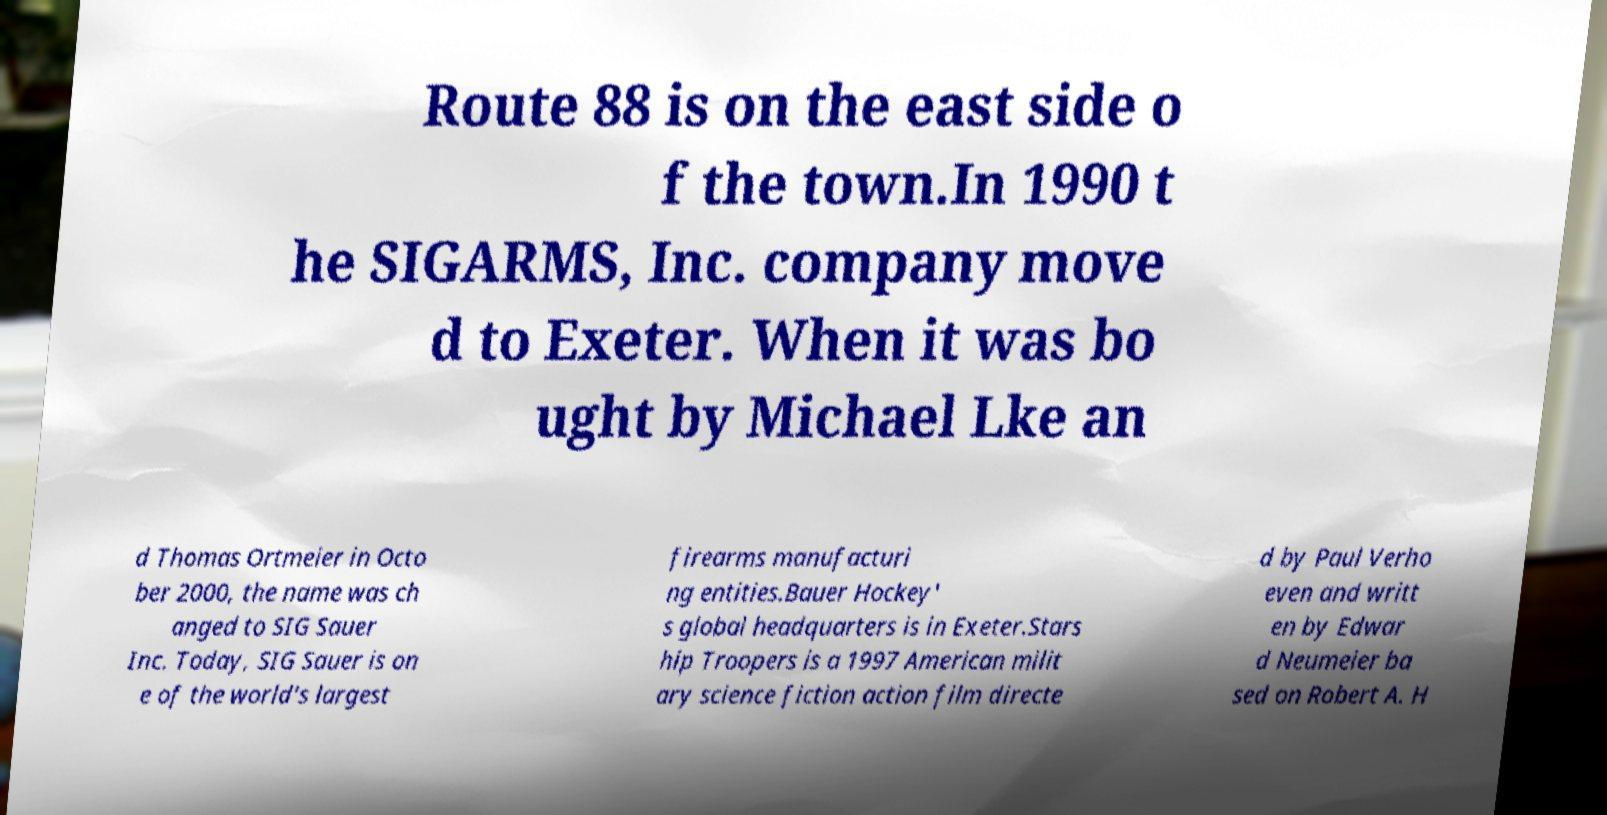Please identify and transcribe the text found in this image. Route 88 is on the east side o f the town.In 1990 t he SIGARMS, Inc. company move d to Exeter. When it was bo ught by Michael Lke an d Thomas Ortmeier in Octo ber 2000, the name was ch anged to SIG Sauer Inc. Today, SIG Sauer is on e of the world's largest firearms manufacturi ng entities.Bauer Hockey' s global headquarters is in Exeter.Stars hip Troopers is a 1997 American milit ary science fiction action film directe d by Paul Verho even and writt en by Edwar d Neumeier ba sed on Robert A. H 